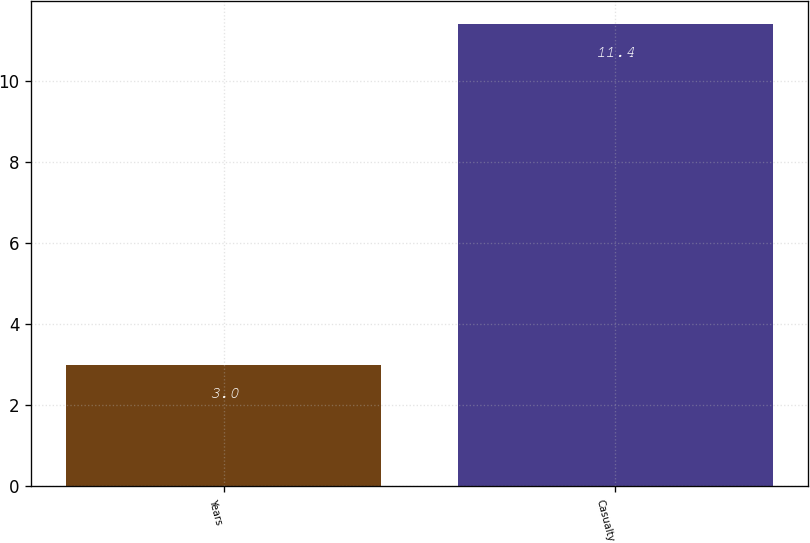Convert chart. <chart><loc_0><loc_0><loc_500><loc_500><bar_chart><fcel>Years<fcel>Casualty<nl><fcel>3<fcel>11.4<nl></chart> 